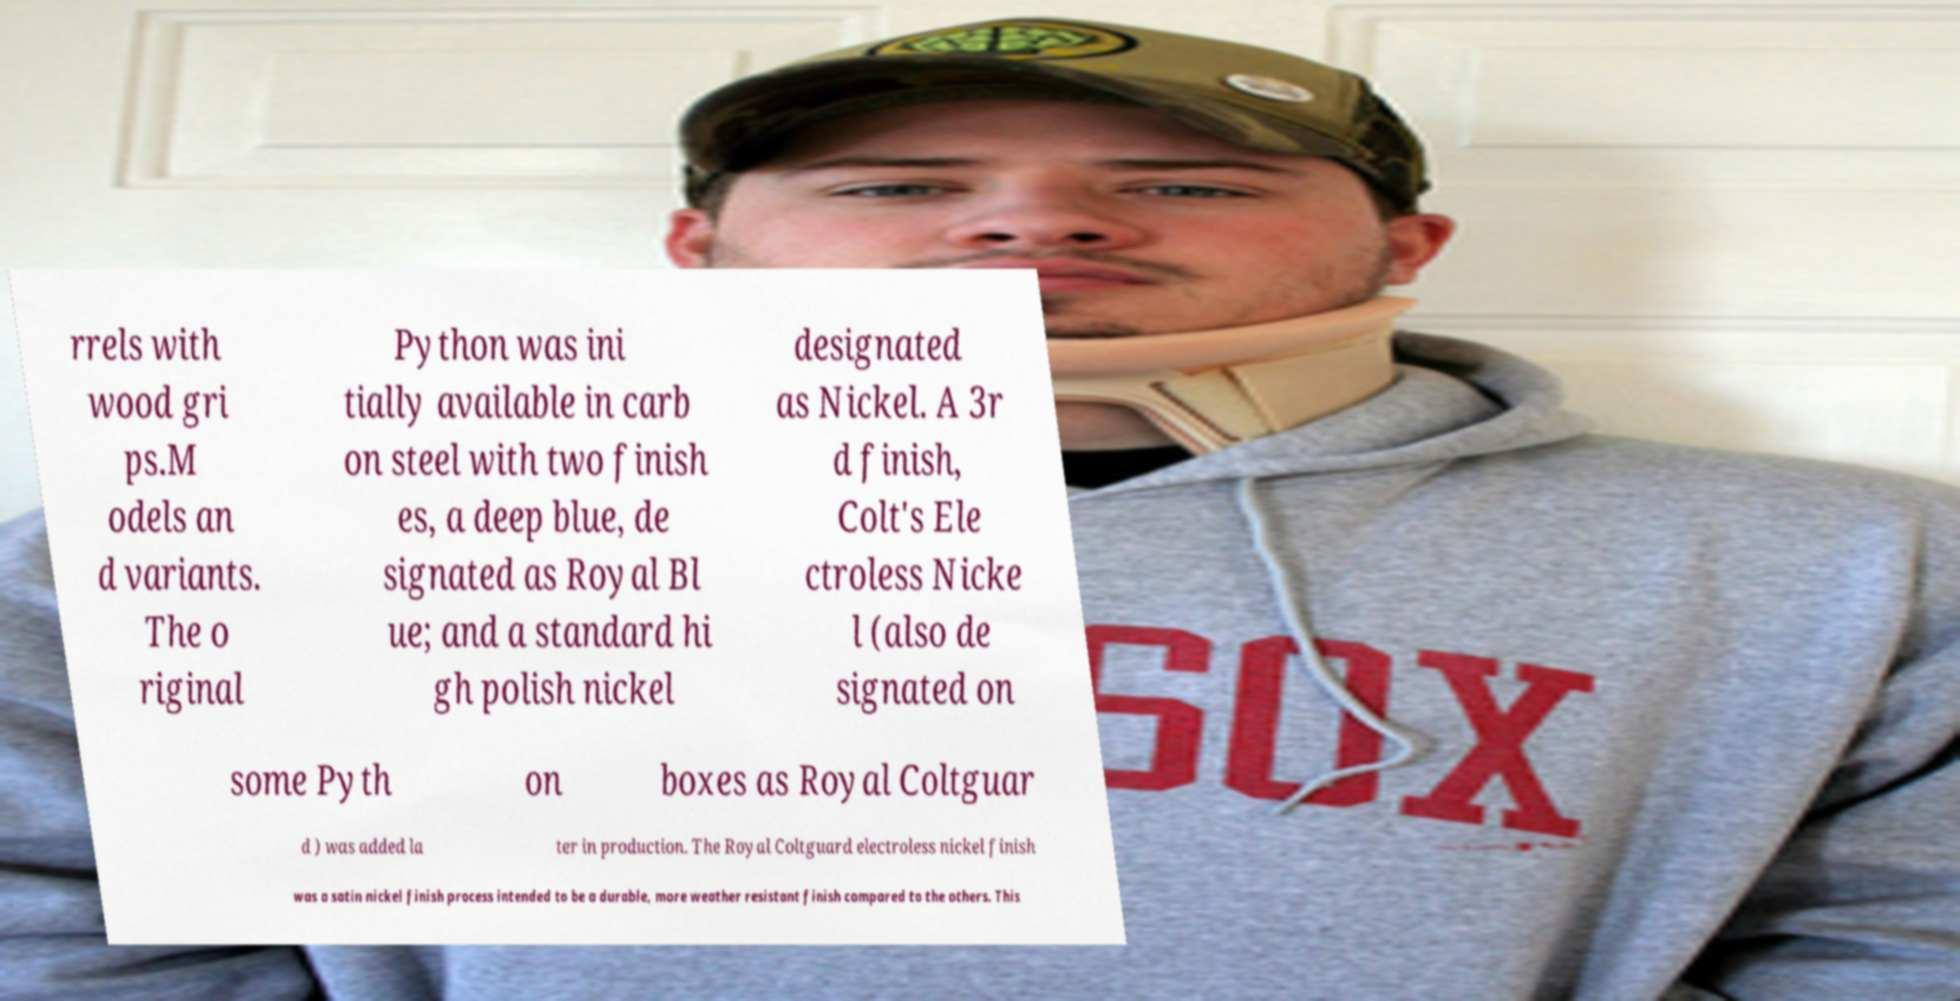For documentation purposes, I need the text within this image transcribed. Could you provide that? rrels with wood gri ps.M odels an d variants. The o riginal Python was ini tially available in carb on steel with two finish es, a deep blue, de signated as Royal Bl ue; and a standard hi gh polish nickel designated as Nickel. A 3r d finish, Colt's Ele ctroless Nicke l (also de signated on some Pyth on boxes as Royal Coltguar d ) was added la ter in production. The Royal Coltguard electroless nickel finish was a satin nickel finish process intended to be a durable, more weather resistant finish compared to the others. This 